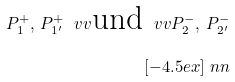<formula> <loc_0><loc_0><loc_500><loc_500>P _ { 1 } ^ { + } , \, P _ { 1 ^ { \prime } } ^ { + } \ v v \text {und} \ v v P _ { 2 } ^ { - } , \, P _ { 2 ^ { \prime } } ^ { - } \\ [ - 4 . 5 e x ] \ n n</formula> 